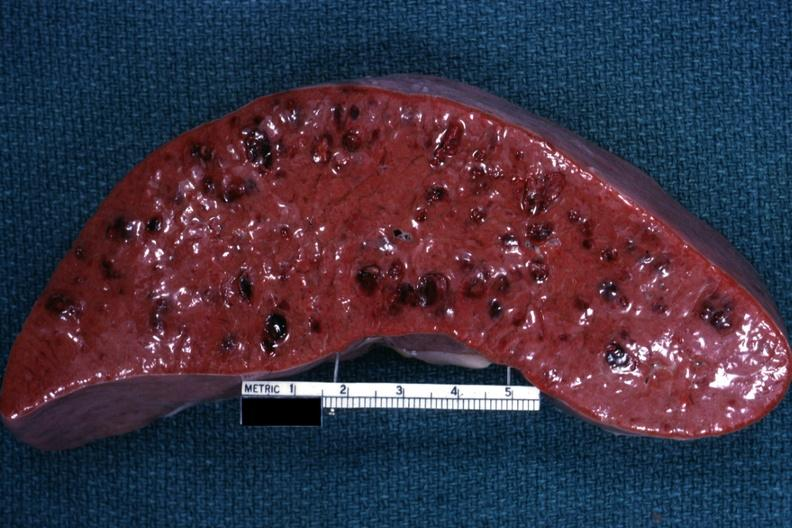where is this part in?
Answer the question using a single word or phrase. Spleen 